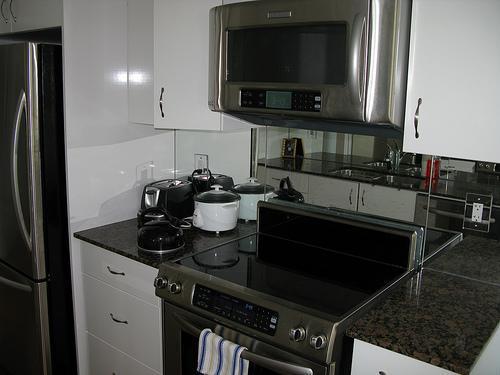How many knobs are on the stove?
Give a very brief answer. 4. 